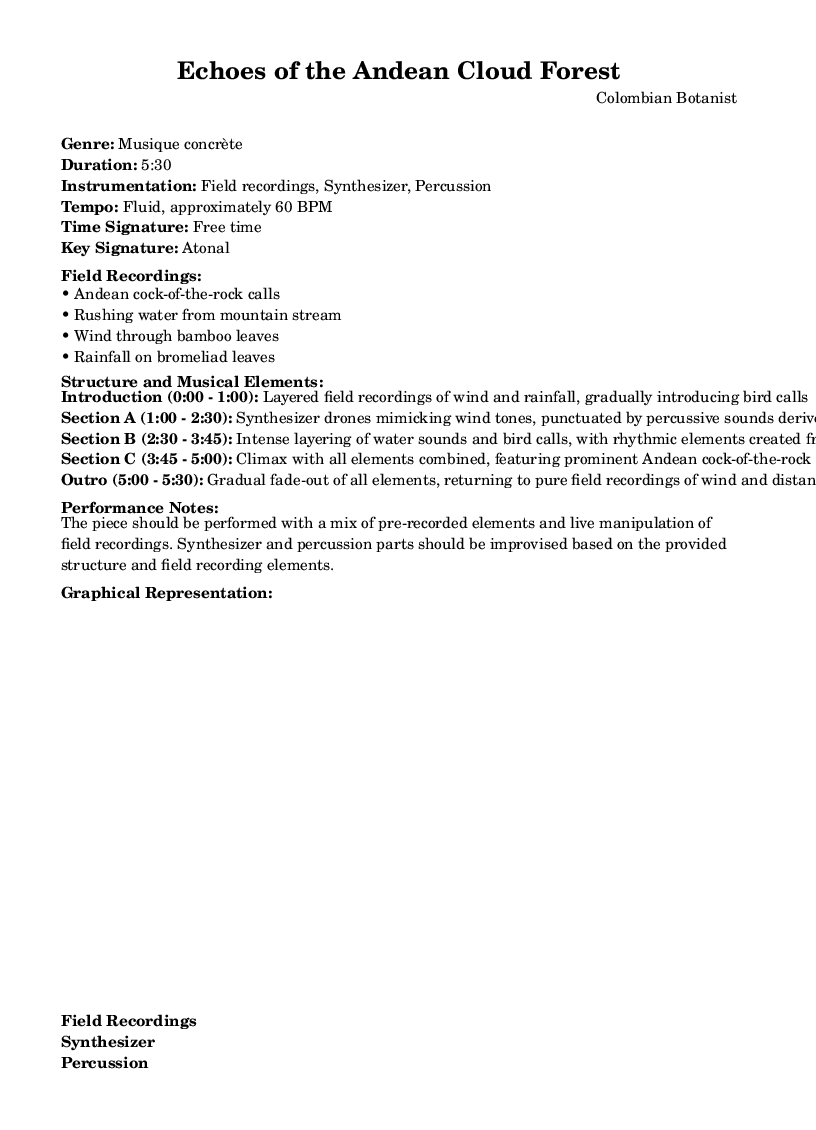What is the genre of this piece? The genre is explicitly stated in the header markup of the sheet music. It identifies the piece as "Musique concrète."
Answer: Musique concrète What is the duration of the composition? The duration is mentioned right under the genre in the header markup. It indicates that the piece lasts "5:30" minutes.
Answer: 5:30 What is the tempo of the piece? The tempo is found in the header markup, directly listed as "Fluid, approximately 60 BPM." It provides an indication of the speed for performing the piece.
Answer: Fluid, approximately 60 BPM How is the introduction structured? The introduction section is outlined in the structure details of the sheet music. It describes it as "Layered field recordings of wind and rainfall, gradually introducing bird calls" and specifies its timing.
Answer: Layered field recordings of wind and rainfall, gradually introducing bird calls In which section do synthesizer drones first appear? To find this, we assess the "Structure and Musical Elements" which details each section. It specifies that Section A introduces synthesizer drones starting from "1:00". Therefore, it can be concluded that synthesizer drones first appear in Section A.
Answer: Section A What type of recordings are used for percussive sounds? The piece outlines various elements in Section A where it states that percussive sounds are derived from bamboo recordings. This kind of reasoning involves reviewing the structural elements related to percussion in the guidelines provided.
Answer: Bamboo recordings What element is prominent in the climax of the piece? The climax is indicated in Section C where it states that it features "prominent Andean cock-of-the-rock calls and synthesizer textures." This identifies the significant element highlighted during the peak of the composition.
Answer: Prominent Andean cock-of-the-rock calls 